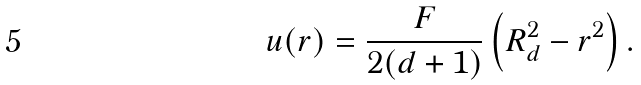<formula> <loc_0><loc_0><loc_500><loc_500>u ( r ) = \frac { F } { 2 ( d + 1 ) } \left ( R _ { d } ^ { 2 } - r ^ { 2 } \right ) .</formula> 